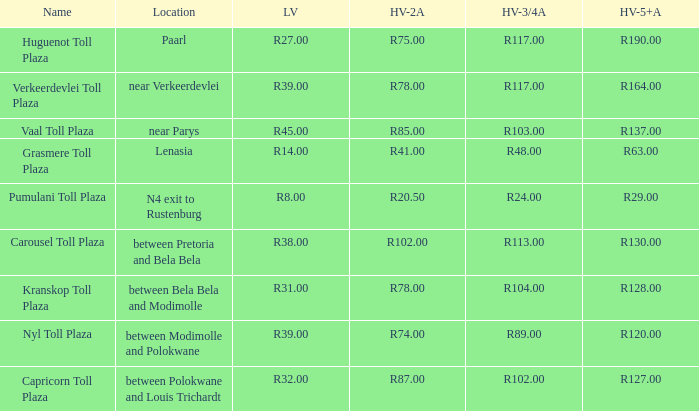What is the name of the plaza where the toll for heavy vehicles with 2 axles is r87.00? Capricorn Toll Plaza. 